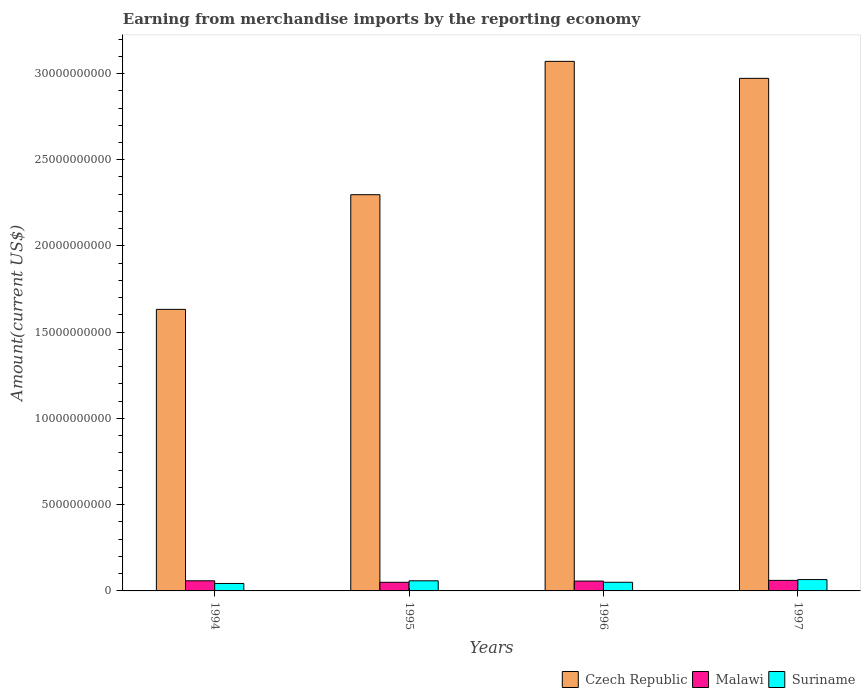How many different coloured bars are there?
Provide a short and direct response. 3. Are the number of bars per tick equal to the number of legend labels?
Give a very brief answer. Yes. Are the number of bars on each tick of the X-axis equal?
Provide a short and direct response. Yes. How many bars are there on the 4th tick from the left?
Provide a succinct answer. 3. In how many cases, is the number of bars for a given year not equal to the number of legend labels?
Provide a short and direct response. 0. What is the amount earned from merchandise imports in Czech Republic in 1997?
Your response must be concise. 2.97e+1. Across all years, what is the maximum amount earned from merchandise imports in Malawi?
Your response must be concise. 6.11e+08. Across all years, what is the minimum amount earned from merchandise imports in Malawi?
Ensure brevity in your answer.  5.00e+08. In which year was the amount earned from merchandise imports in Czech Republic maximum?
Provide a succinct answer. 1996. In which year was the amount earned from merchandise imports in Malawi minimum?
Keep it short and to the point. 1995. What is the total amount earned from merchandise imports in Malawi in the graph?
Your answer should be very brief. 2.27e+09. What is the difference between the amount earned from merchandise imports in Malawi in 1994 and that in 1996?
Make the answer very short. 1.75e+07. What is the difference between the amount earned from merchandise imports in Suriname in 1996 and the amount earned from merchandise imports in Malawi in 1994?
Offer a terse response. -8.61e+07. What is the average amount earned from merchandise imports in Czech Republic per year?
Your answer should be compact. 2.49e+1. In the year 1997, what is the difference between the amount earned from merchandise imports in Suriname and amount earned from merchandise imports in Malawi?
Provide a short and direct response. 4.69e+07. In how many years, is the amount earned from merchandise imports in Malawi greater than 26000000000 US$?
Make the answer very short. 0. What is the ratio of the amount earned from merchandise imports in Malawi in 1995 to that in 1997?
Your answer should be very brief. 0.82. Is the difference between the amount earned from merchandise imports in Suriname in 1995 and 1997 greater than the difference between the amount earned from merchandise imports in Malawi in 1995 and 1997?
Your answer should be very brief. Yes. What is the difference between the highest and the second highest amount earned from merchandise imports in Suriname?
Provide a succinct answer. 7.20e+07. What is the difference between the highest and the lowest amount earned from merchandise imports in Suriname?
Your response must be concise. 2.26e+08. What does the 1st bar from the left in 1994 represents?
Your answer should be compact. Czech Republic. What does the 1st bar from the right in 1996 represents?
Offer a very short reply. Suriname. Are the values on the major ticks of Y-axis written in scientific E-notation?
Keep it short and to the point. No. Does the graph contain grids?
Your response must be concise. No. What is the title of the graph?
Provide a short and direct response. Earning from merchandise imports by the reporting economy. Does "Cuba" appear as one of the legend labels in the graph?
Your answer should be compact. No. What is the label or title of the X-axis?
Provide a short and direct response. Years. What is the label or title of the Y-axis?
Make the answer very short. Amount(current US$). What is the Amount(current US$) in Czech Republic in 1994?
Your answer should be very brief. 1.63e+1. What is the Amount(current US$) of Malawi in 1994?
Your response must be concise. 5.88e+08. What is the Amount(current US$) in Suriname in 1994?
Provide a succinct answer. 4.33e+08. What is the Amount(current US$) in Czech Republic in 1995?
Offer a terse response. 2.30e+1. What is the Amount(current US$) of Malawi in 1995?
Offer a very short reply. 5.00e+08. What is the Amount(current US$) in Suriname in 1995?
Your response must be concise. 5.86e+08. What is the Amount(current US$) in Czech Republic in 1996?
Your answer should be compact. 3.07e+1. What is the Amount(current US$) of Malawi in 1996?
Your answer should be compact. 5.70e+08. What is the Amount(current US$) in Suriname in 1996?
Your answer should be compact. 5.02e+08. What is the Amount(current US$) in Czech Republic in 1997?
Keep it short and to the point. 2.97e+1. What is the Amount(current US$) in Malawi in 1997?
Keep it short and to the point. 6.11e+08. What is the Amount(current US$) in Suriname in 1997?
Your answer should be compact. 6.58e+08. Across all years, what is the maximum Amount(current US$) of Czech Republic?
Your answer should be compact. 3.07e+1. Across all years, what is the maximum Amount(current US$) in Malawi?
Provide a short and direct response. 6.11e+08. Across all years, what is the maximum Amount(current US$) of Suriname?
Offer a terse response. 6.58e+08. Across all years, what is the minimum Amount(current US$) of Czech Republic?
Provide a short and direct response. 1.63e+1. Across all years, what is the minimum Amount(current US$) in Malawi?
Provide a succinct answer. 5.00e+08. Across all years, what is the minimum Amount(current US$) of Suriname?
Keep it short and to the point. 4.33e+08. What is the total Amount(current US$) in Czech Republic in the graph?
Offer a terse response. 9.97e+1. What is the total Amount(current US$) of Malawi in the graph?
Your answer should be very brief. 2.27e+09. What is the total Amount(current US$) of Suriname in the graph?
Offer a terse response. 2.18e+09. What is the difference between the Amount(current US$) of Czech Republic in 1994 and that in 1995?
Make the answer very short. -6.65e+09. What is the difference between the Amount(current US$) in Malawi in 1994 and that in 1995?
Ensure brevity in your answer.  8.72e+07. What is the difference between the Amount(current US$) of Suriname in 1994 and that in 1995?
Provide a short and direct response. -1.54e+08. What is the difference between the Amount(current US$) in Czech Republic in 1994 and that in 1996?
Keep it short and to the point. -1.44e+1. What is the difference between the Amount(current US$) in Malawi in 1994 and that in 1996?
Provide a succinct answer. 1.75e+07. What is the difference between the Amount(current US$) in Suriname in 1994 and that in 1996?
Provide a succinct answer. -6.91e+07. What is the difference between the Amount(current US$) of Czech Republic in 1994 and that in 1997?
Offer a very short reply. -1.34e+1. What is the difference between the Amount(current US$) in Malawi in 1994 and that in 1997?
Make the answer very short. -2.36e+07. What is the difference between the Amount(current US$) of Suriname in 1994 and that in 1997?
Keep it short and to the point. -2.26e+08. What is the difference between the Amount(current US$) in Czech Republic in 1995 and that in 1996?
Offer a very short reply. -7.73e+09. What is the difference between the Amount(current US$) in Malawi in 1995 and that in 1996?
Provide a succinct answer. -6.97e+07. What is the difference between the Amount(current US$) in Suriname in 1995 and that in 1996?
Your answer should be very brief. 8.46e+07. What is the difference between the Amount(current US$) in Czech Republic in 1995 and that in 1997?
Provide a short and direct response. -6.75e+09. What is the difference between the Amount(current US$) of Malawi in 1995 and that in 1997?
Offer a very short reply. -1.11e+08. What is the difference between the Amount(current US$) in Suriname in 1995 and that in 1997?
Keep it short and to the point. -7.20e+07. What is the difference between the Amount(current US$) of Czech Republic in 1996 and that in 1997?
Give a very brief answer. 9.86e+08. What is the difference between the Amount(current US$) in Malawi in 1996 and that in 1997?
Keep it short and to the point. -4.11e+07. What is the difference between the Amount(current US$) in Suriname in 1996 and that in 1997?
Offer a terse response. -1.57e+08. What is the difference between the Amount(current US$) of Czech Republic in 1994 and the Amount(current US$) of Malawi in 1995?
Ensure brevity in your answer.  1.58e+1. What is the difference between the Amount(current US$) of Czech Republic in 1994 and the Amount(current US$) of Suriname in 1995?
Give a very brief answer. 1.57e+1. What is the difference between the Amount(current US$) in Malawi in 1994 and the Amount(current US$) in Suriname in 1995?
Give a very brief answer. 1.50e+06. What is the difference between the Amount(current US$) of Czech Republic in 1994 and the Amount(current US$) of Malawi in 1996?
Your answer should be compact. 1.58e+1. What is the difference between the Amount(current US$) in Czech Republic in 1994 and the Amount(current US$) in Suriname in 1996?
Provide a short and direct response. 1.58e+1. What is the difference between the Amount(current US$) of Malawi in 1994 and the Amount(current US$) of Suriname in 1996?
Provide a short and direct response. 8.61e+07. What is the difference between the Amount(current US$) in Czech Republic in 1994 and the Amount(current US$) in Malawi in 1997?
Make the answer very short. 1.57e+1. What is the difference between the Amount(current US$) of Czech Republic in 1994 and the Amount(current US$) of Suriname in 1997?
Offer a very short reply. 1.57e+1. What is the difference between the Amount(current US$) in Malawi in 1994 and the Amount(current US$) in Suriname in 1997?
Provide a succinct answer. -7.05e+07. What is the difference between the Amount(current US$) in Czech Republic in 1995 and the Amount(current US$) in Malawi in 1996?
Offer a terse response. 2.24e+1. What is the difference between the Amount(current US$) of Czech Republic in 1995 and the Amount(current US$) of Suriname in 1996?
Your answer should be compact. 2.25e+1. What is the difference between the Amount(current US$) of Malawi in 1995 and the Amount(current US$) of Suriname in 1996?
Offer a terse response. -1.13e+06. What is the difference between the Amount(current US$) in Czech Republic in 1995 and the Amount(current US$) in Malawi in 1997?
Provide a short and direct response. 2.24e+1. What is the difference between the Amount(current US$) of Czech Republic in 1995 and the Amount(current US$) of Suriname in 1997?
Your response must be concise. 2.23e+1. What is the difference between the Amount(current US$) of Malawi in 1995 and the Amount(current US$) of Suriname in 1997?
Keep it short and to the point. -1.58e+08. What is the difference between the Amount(current US$) of Czech Republic in 1996 and the Amount(current US$) of Malawi in 1997?
Make the answer very short. 3.01e+1. What is the difference between the Amount(current US$) in Czech Republic in 1996 and the Amount(current US$) in Suriname in 1997?
Give a very brief answer. 3.00e+1. What is the difference between the Amount(current US$) of Malawi in 1996 and the Amount(current US$) of Suriname in 1997?
Ensure brevity in your answer.  -8.80e+07. What is the average Amount(current US$) in Czech Republic per year?
Give a very brief answer. 2.49e+1. What is the average Amount(current US$) in Malawi per year?
Offer a terse response. 5.67e+08. What is the average Amount(current US$) of Suriname per year?
Offer a terse response. 5.45e+08. In the year 1994, what is the difference between the Amount(current US$) in Czech Republic and Amount(current US$) in Malawi?
Your answer should be compact. 1.57e+1. In the year 1994, what is the difference between the Amount(current US$) in Czech Republic and Amount(current US$) in Suriname?
Provide a succinct answer. 1.59e+1. In the year 1994, what is the difference between the Amount(current US$) in Malawi and Amount(current US$) in Suriname?
Your answer should be compact. 1.55e+08. In the year 1995, what is the difference between the Amount(current US$) in Czech Republic and Amount(current US$) in Malawi?
Provide a succinct answer. 2.25e+1. In the year 1995, what is the difference between the Amount(current US$) of Czech Republic and Amount(current US$) of Suriname?
Provide a succinct answer. 2.24e+1. In the year 1995, what is the difference between the Amount(current US$) of Malawi and Amount(current US$) of Suriname?
Your answer should be very brief. -8.57e+07. In the year 1996, what is the difference between the Amount(current US$) of Czech Republic and Amount(current US$) of Malawi?
Your answer should be compact. 3.01e+1. In the year 1996, what is the difference between the Amount(current US$) of Czech Republic and Amount(current US$) of Suriname?
Provide a short and direct response. 3.02e+1. In the year 1996, what is the difference between the Amount(current US$) in Malawi and Amount(current US$) in Suriname?
Provide a short and direct response. 6.86e+07. In the year 1997, what is the difference between the Amount(current US$) of Czech Republic and Amount(current US$) of Malawi?
Offer a very short reply. 2.91e+1. In the year 1997, what is the difference between the Amount(current US$) of Czech Republic and Amount(current US$) of Suriname?
Offer a very short reply. 2.91e+1. In the year 1997, what is the difference between the Amount(current US$) in Malawi and Amount(current US$) in Suriname?
Keep it short and to the point. -4.69e+07. What is the ratio of the Amount(current US$) in Czech Republic in 1994 to that in 1995?
Your response must be concise. 0.71. What is the ratio of the Amount(current US$) of Malawi in 1994 to that in 1995?
Your answer should be compact. 1.17. What is the ratio of the Amount(current US$) in Suriname in 1994 to that in 1995?
Provide a succinct answer. 0.74. What is the ratio of the Amount(current US$) in Czech Republic in 1994 to that in 1996?
Your answer should be compact. 0.53. What is the ratio of the Amount(current US$) of Malawi in 1994 to that in 1996?
Offer a terse response. 1.03. What is the ratio of the Amount(current US$) of Suriname in 1994 to that in 1996?
Offer a terse response. 0.86. What is the ratio of the Amount(current US$) of Czech Republic in 1994 to that in 1997?
Provide a short and direct response. 0.55. What is the ratio of the Amount(current US$) in Malawi in 1994 to that in 1997?
Your answer should be very brief. 0.96. What is the ratio of the Amount(current US$) of Suriname in 1994 to that in 1997?
Keep it short and to the point. 0.66. What is the ratio of the Amount(current US$) in Czech Republic in 1995 to that in 1996?
Your response must be concise. 0.75. What is the ratio of the Amount(current US$) of Malawi in 1995 to that in 1996?
Make the answer very short. 0.88. What is the ratio of the Amount(current US$) of Suriname in 1995 to that in 1996?
Offer a very short reply. 1.17. What is the ratio of the Amount(current US$) in Czech Republic in 1995 to that in 1997?
Provide a short and direct response. 0.77. What is the ratio of the Amount(current US$) in Malawi in 1995 to that in 1997?
Provide a succinct answer. 0.82. What is the ratio of the Amount(current US$) of Suriname in 1995 to that in 1997?
Keep it short and to the point. 0.89. What is the ratio of the Amount(current US$) of Czech Republic in 1996 to that in 1997?
Ensure brevity in your answer.  1.03. What is the ratio of the Amount(current US$) of Malawi in 1996 to that in 1997?
Provide a short and direct response. 0.93. What is the ratio of the Amount(current US$) of Suriname in 1996 to that in 1997?
Keep it short and to the point. 0.76. What is the difference between the highest and the second highest Amount(current US$) of Czech Republic?
Your answer should be very brief. 9.86e+08. What is the difference between the highest and the second highest Amount(current US$) of Malawi?
Your answer should be very brief. 2.36e+07. What is the difference between the highest and the second highest Amount(current US$) in Suriname?
Your answer should be compact. 7.20e+07. What is the difference between the highest and the lowest Amount(current US$) in Czech Republic?
Provide a succinct answer. 1.44e+1. What is the difference between the highest and the lowest Amount(current US$) of Malawi?
Your answer should be compact. 1.11e+08. What is the difference between the highest and the lowest Amount(current US$) of Suriname?
Offer a very short reply. 2.26e+08. 